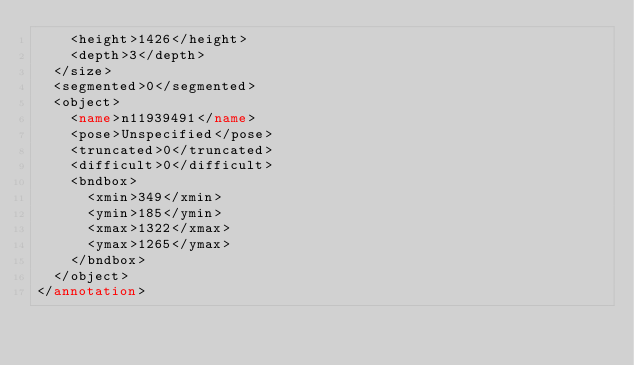Convert code to text. <code><loc_0><loc_0><loc_500><loc_500><_XML_>		<height>1426</height>
		<depth>3</depth>
	</size>
	<segmented>0</segmented>
	<object>
		<name>n11939491</name>
		<pose>Unspecified</pose>
		<truncated>0</truncated>
		<difficult>0</difficult>
		<bndbox>
			<xmin>349</xmin>
			<ymin>185</ymin>
			<xmax>1322</xmax>
			<ymax>1265</ymax>
		</bndbox>
	</object>
</annotation></code> 